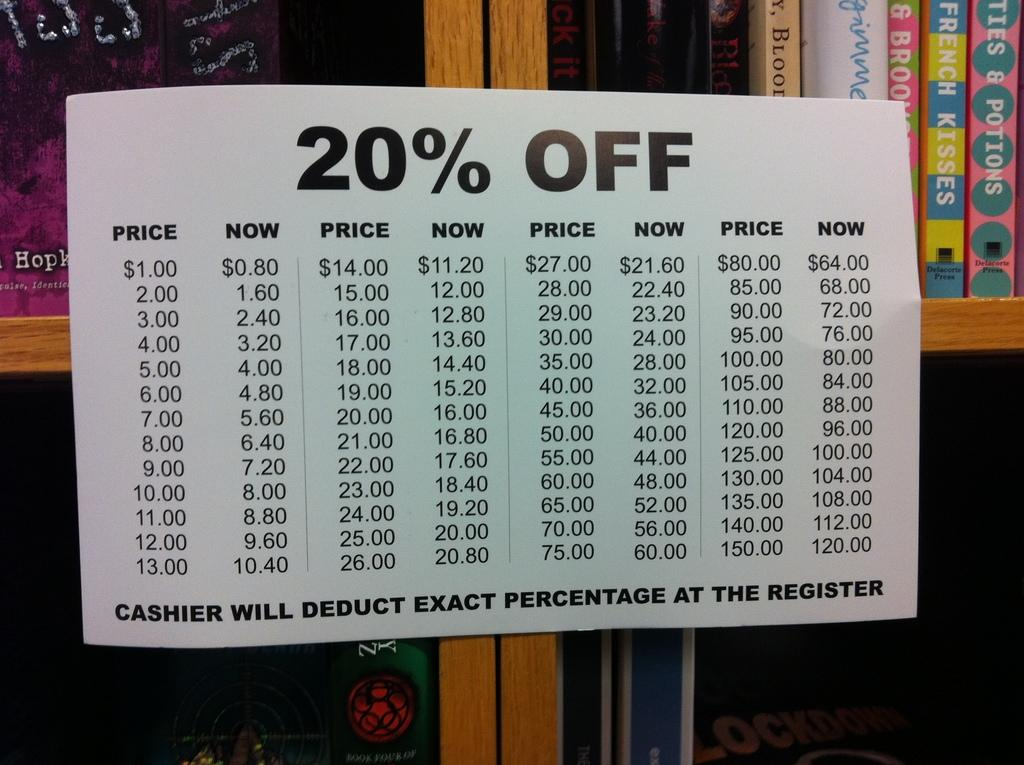<image>
Share a concise interpretation of the image provided. a 20 percent off label on a white sign 